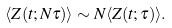Convert formula to latex. <formula><loc_0><loc_0><loc_500><loc_500>\langle Z ( t ; N \tau ) \rangle \sim N \langle Z ( t ; \tau ) \rangle .</formula> 